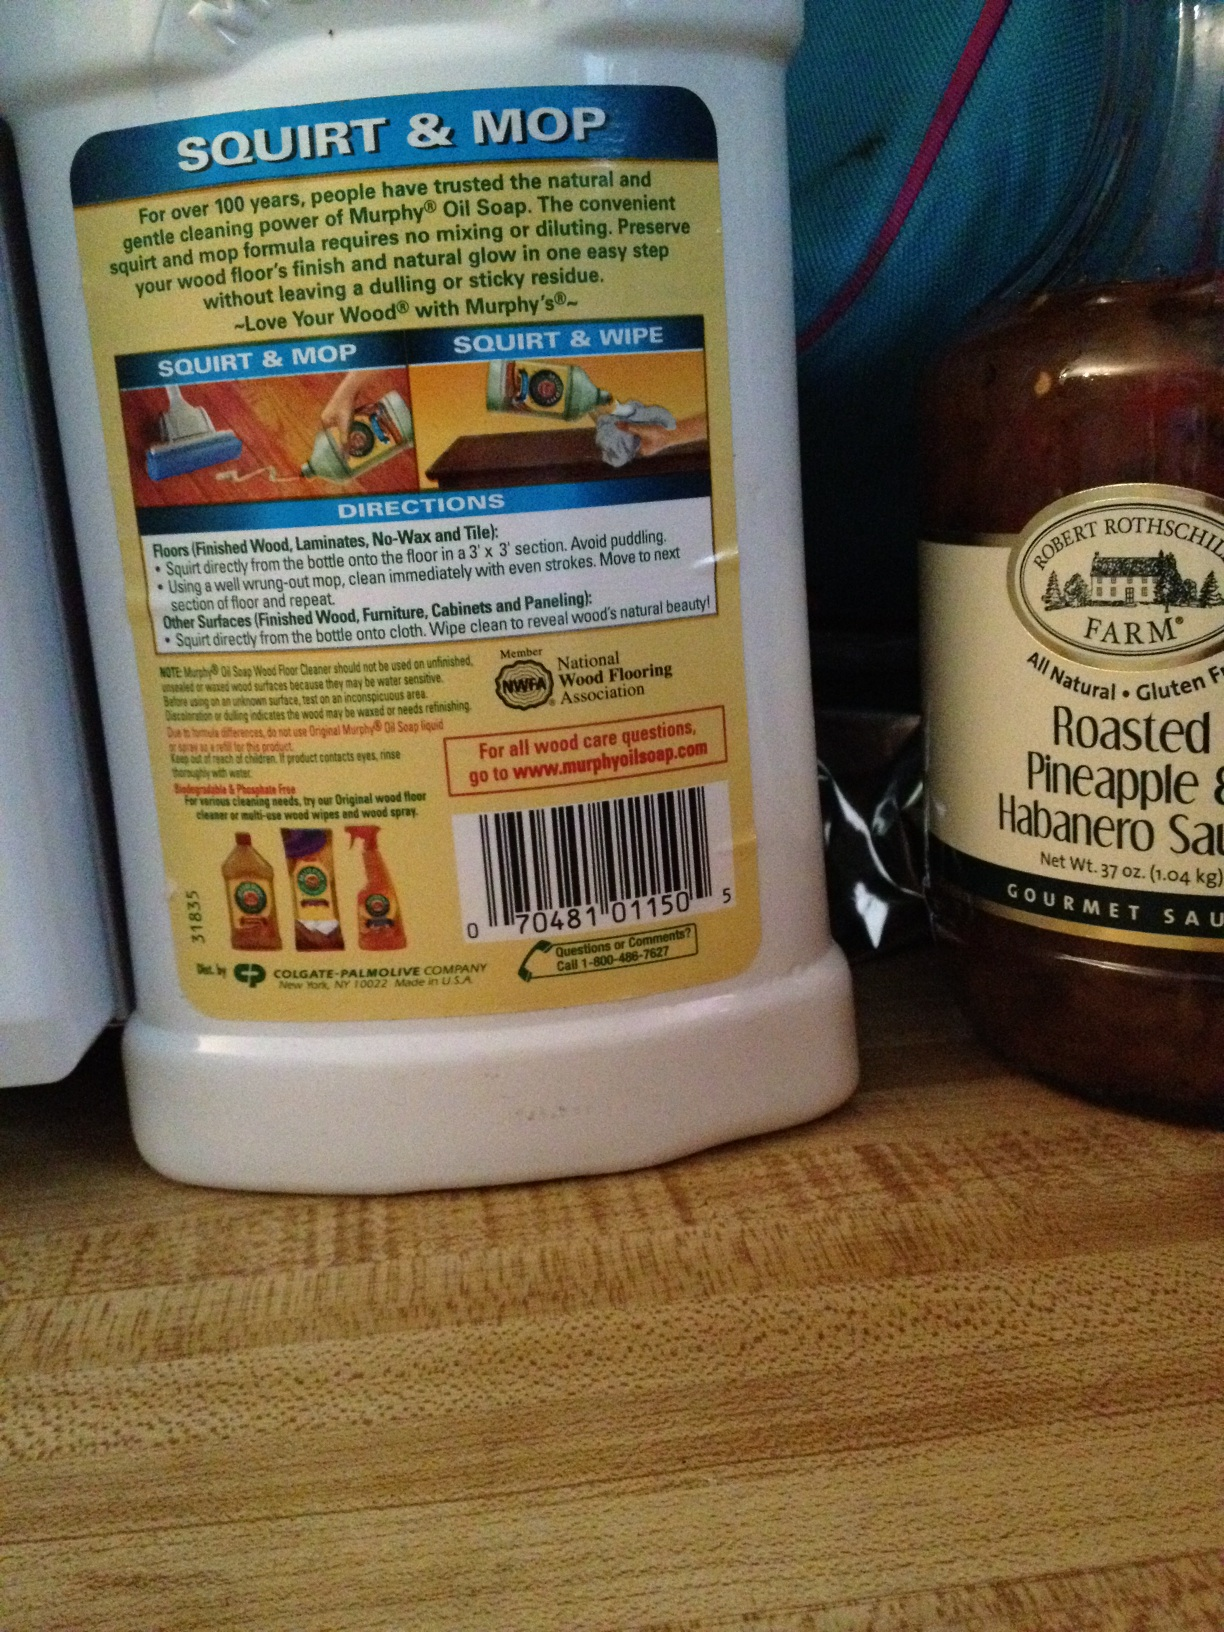Can you describe the instructions given for using the Murphy’s Oil Soap? According to the label, you should squirt directly from the bottle onto the cleaning surface in a 3' x 3' section and clean immediately with even strokes. It advises to avoid puddling. This one-step method simplifies cleaning and preserves floor quality without leaving a dulling or sticky residue. 